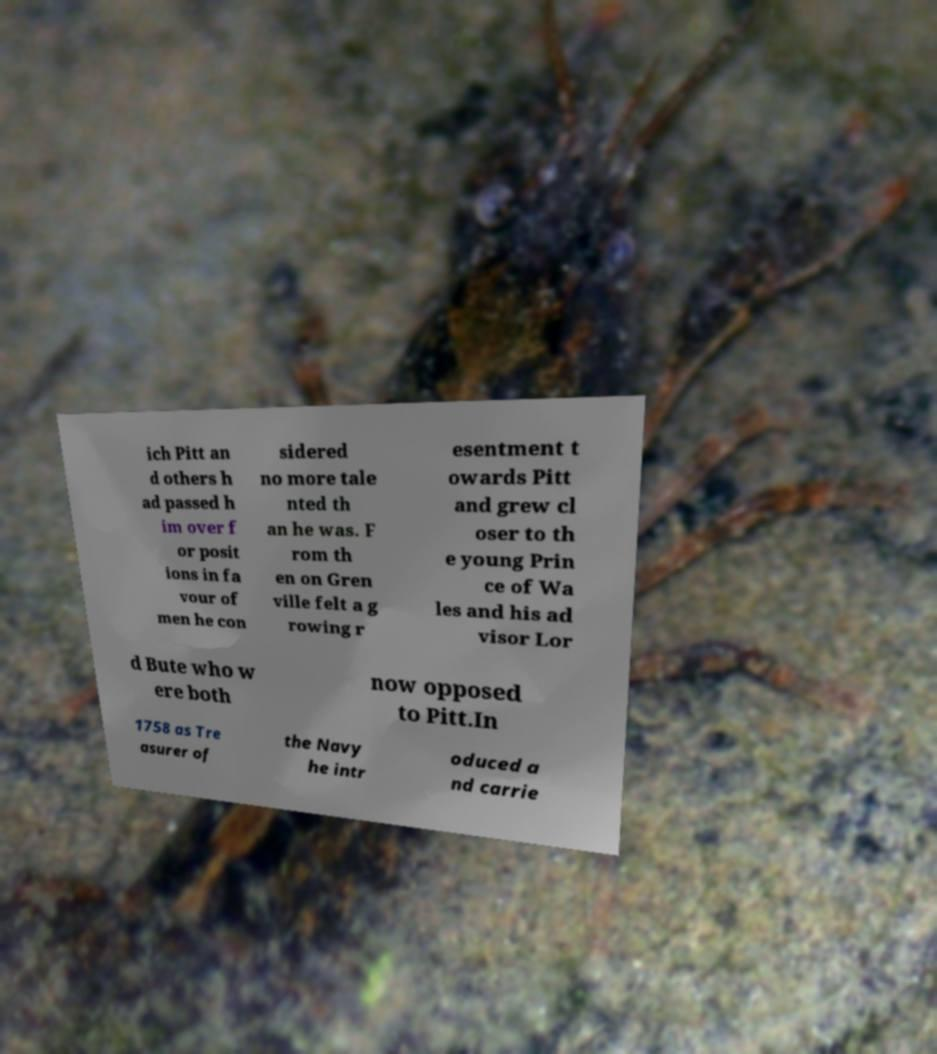Please identify and transcribe the text found in this image. ich Pitt an d others h ad passed h im over f or posit ions in fa vour of men he con sidered no more tale nted th an he was. F rom th en on Gren ville felt a g rowing r esentment t owards Pitt and grew cl oser to th e young Prin ce of Wa les and his ad visor Lor d Bute who w ere both now opposed to Pitt.In 1758 as Tre asurer of the Navy he intr oduced a nd carrie 